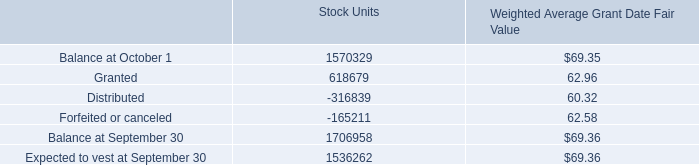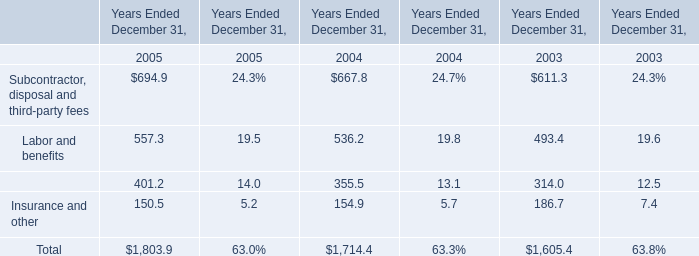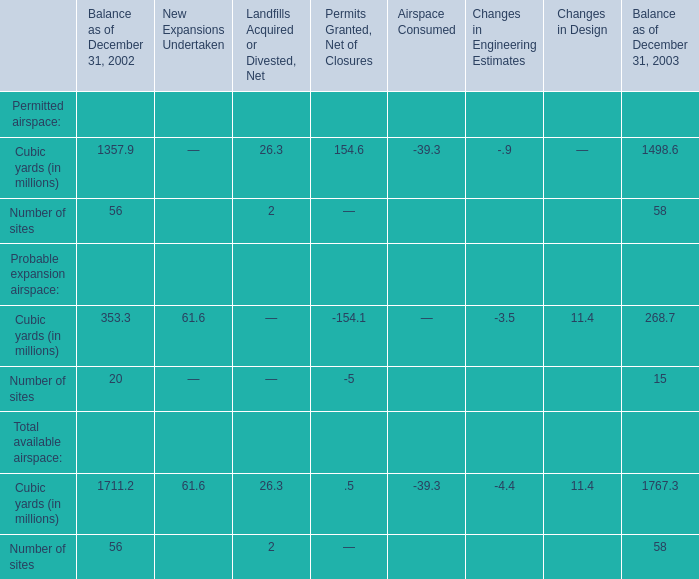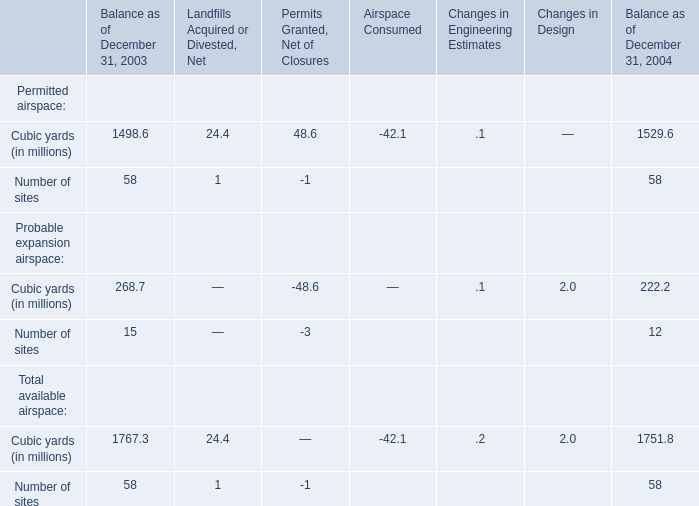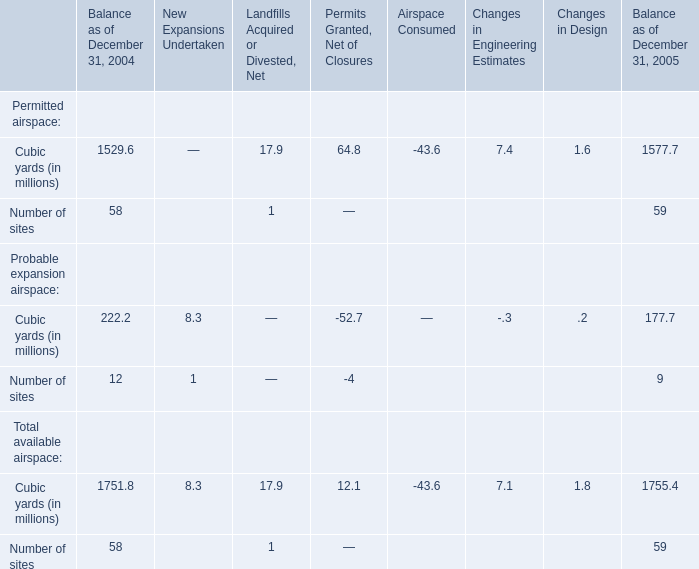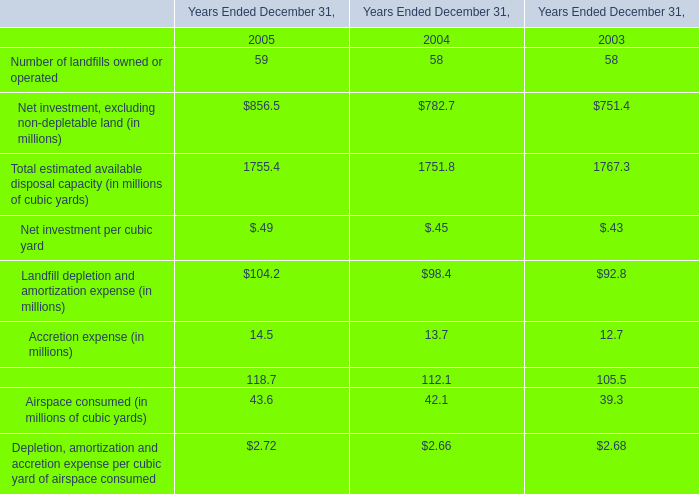what is the average of total fair value of time-vested restricted stock units vested during 2009 , 2008 and 2007? 
Computations: (((29535 + 26674) + 3392) / 3)
Answer: 19867.0. 